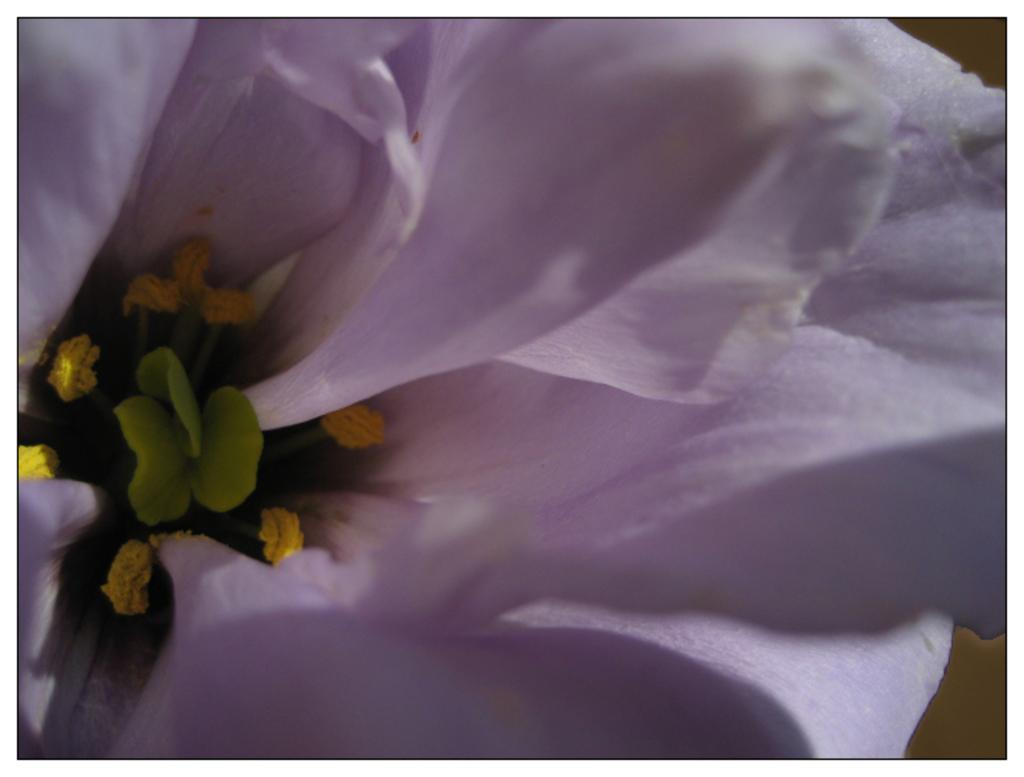What type of flower is present in the image? There is a white flower in the image. How many eggs are being whipped in the image? There are no eggs or whipping activity present in the image; it features a white flower. What type of trouble is depicted in the image? There is no trouble depicted in the image; it features a white flower. 